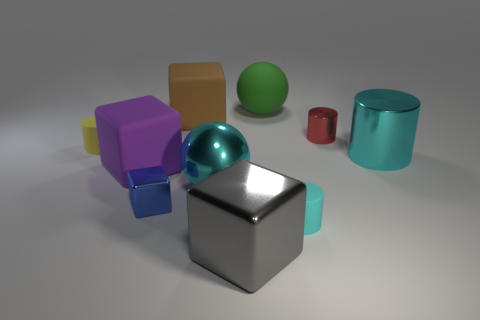Is the shape of the tiny metallic object that is right of the large shiny cube the same as  the blue thing?
Provide a short and direct response. No. What is the size of the matte thing that is the same color as the large metallic ball?
Provide a succinct answer. Small. Is the color of the large cylinder the same as the rubber cylinder to the right of the big gray metal object?
Provide a succinct answer. Yes. There is a big ball in front of the large cyan cylinder; does it have the same color as the large shiny cylinder?
Your response must be concise. Yes. How many large things are both on the right side of the matte ball and left of the tiny cube?
Offer a very short reply. 0. What is the shape of the large shiny thing that is the same color as the big metal sphere?
Make the answer very short. Cylinder. Does the large brown cube have the same material as the purple block?
Give a very brief answer. Yes. There is a small matte object in front of the big cyan metal ball that is on the left side of the large cyan metallic thing to the right of the green object; what is its shape?
Make the answer very short. Cylinder. Are there fewer cyan metal objects on the left side of the big cylinder than large green rubber objects that are in front of the tiny yellow matte thing?
Your answer should be very brief. No. The metal object that is to the left of the big rubber cube to the right of the tiny blue block is what shape?
Your answer should be compact. Cube. 